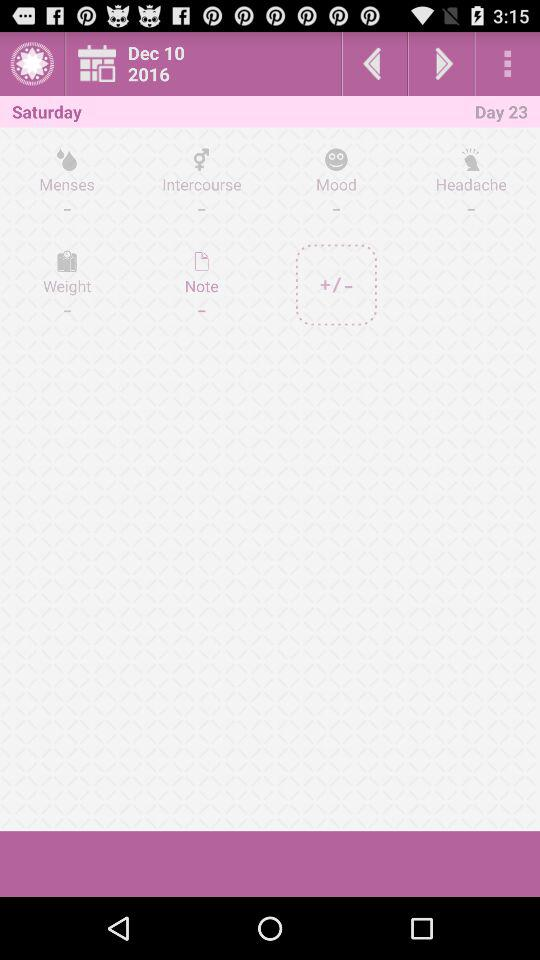What day falls on day 23? The day is "Saturday". 